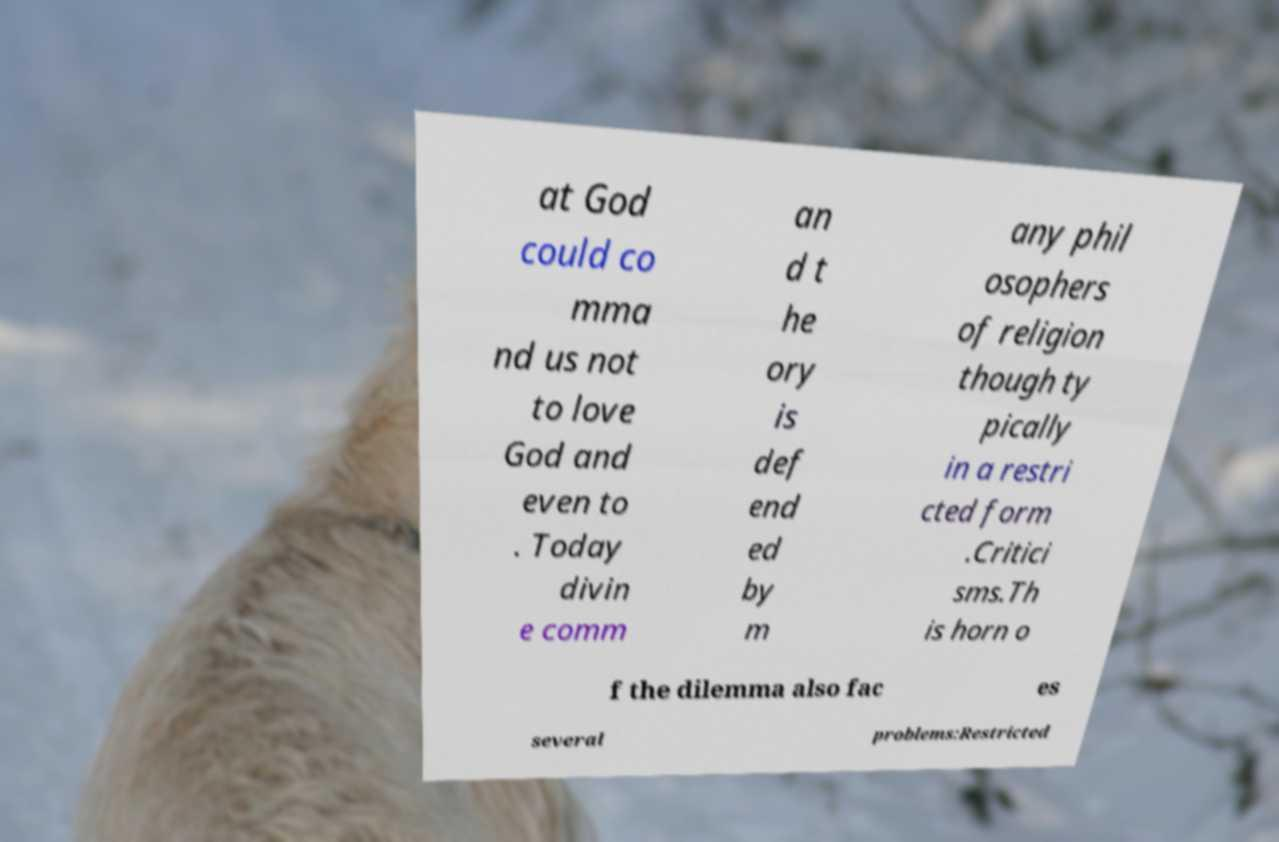I need the written content from this picture converted into text. Can you do that? at God could co mma nd us not to love God and even to . Today divin e comm an d t he ory is def end ed by m any phil osophers of religion though ty pically in a restri cted form .Critici sms.Th is horn o f the dilemma also fac es several problems:Restricted 